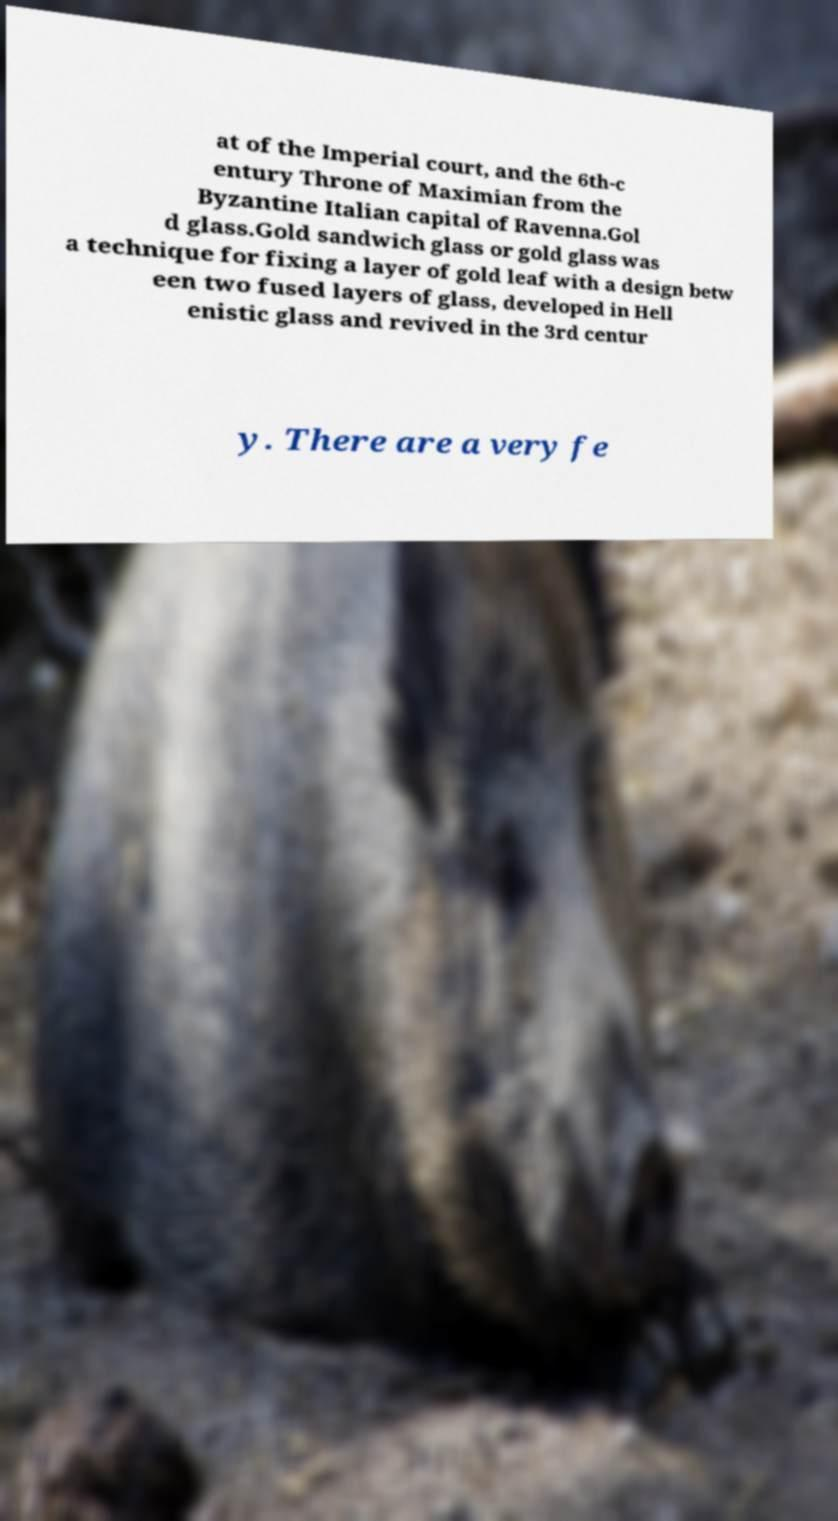Can you read and provide the text displayed in the image?This photo seems to have some interesting text. Can you extract and type it out for me? at of the Imperial court, and the 6th-c entury Throne of Maximian from the Byzantine Italian capital of Ravenna.Gol d glass.Gold sandwich glass or gold glass was a technique for fixing a layer of gold leaf with a design betw een two fused layers of glass, developed in Hell enistic glass and revived in the 3rd centur y. There are a very fe 